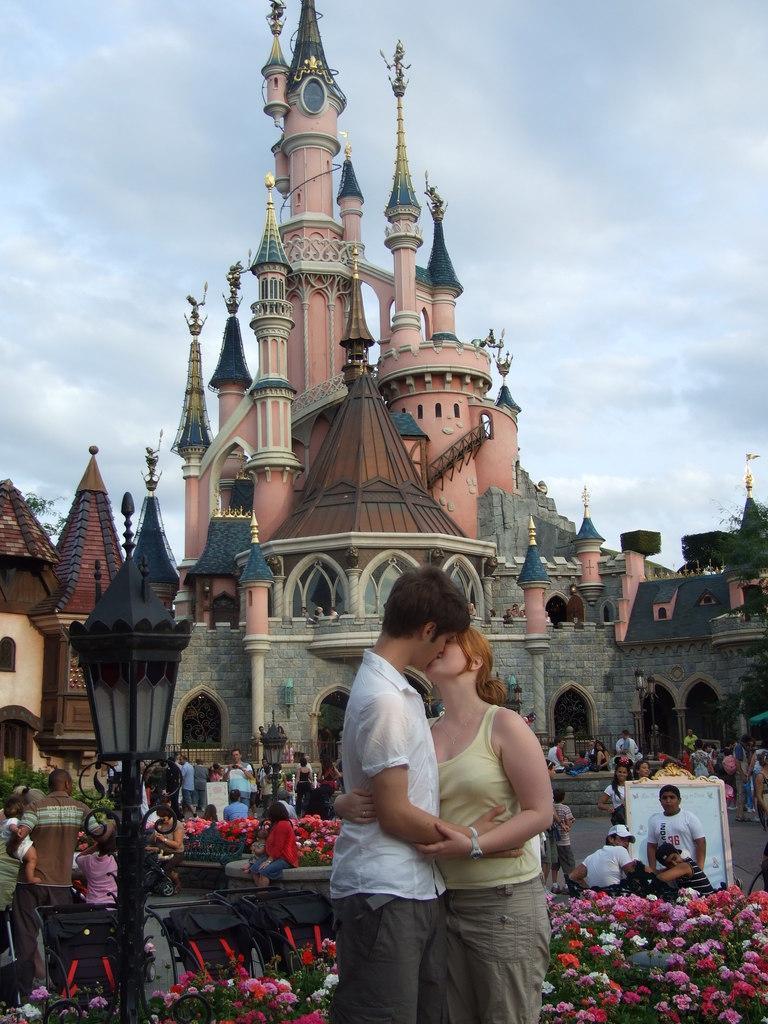Please provide a concise description of this image. In this image, we can see some people, buildings, poles, plants and flowers. We can see the ground with some objects. We can see some black colored objects, a board. We can see the sky with clouds. 